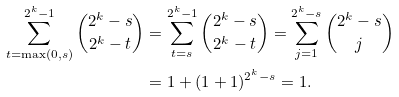<formula> <loc_0><loc_0><loc_500><loc_500>\sum _ { t = \max ( 0 , s ) } ^ { 2 ^ { k } - 1 } { 2 ^ { k } - s \choose 2 ^ { k } - t } & = \sum _ { t = s } ^ { 2 ^ { k } - 1 } { 2 ^ { k } - s \choose 2 ^ { k } - t } = \sum _ { j = 1 } ^ { 2 ^ { k } - s } { 2 ^ { k } - s \choose j } \\ & = 1 + ( 1 + 1 ) ^ { 2 ^ { k } - s } = 1 .</formula> 